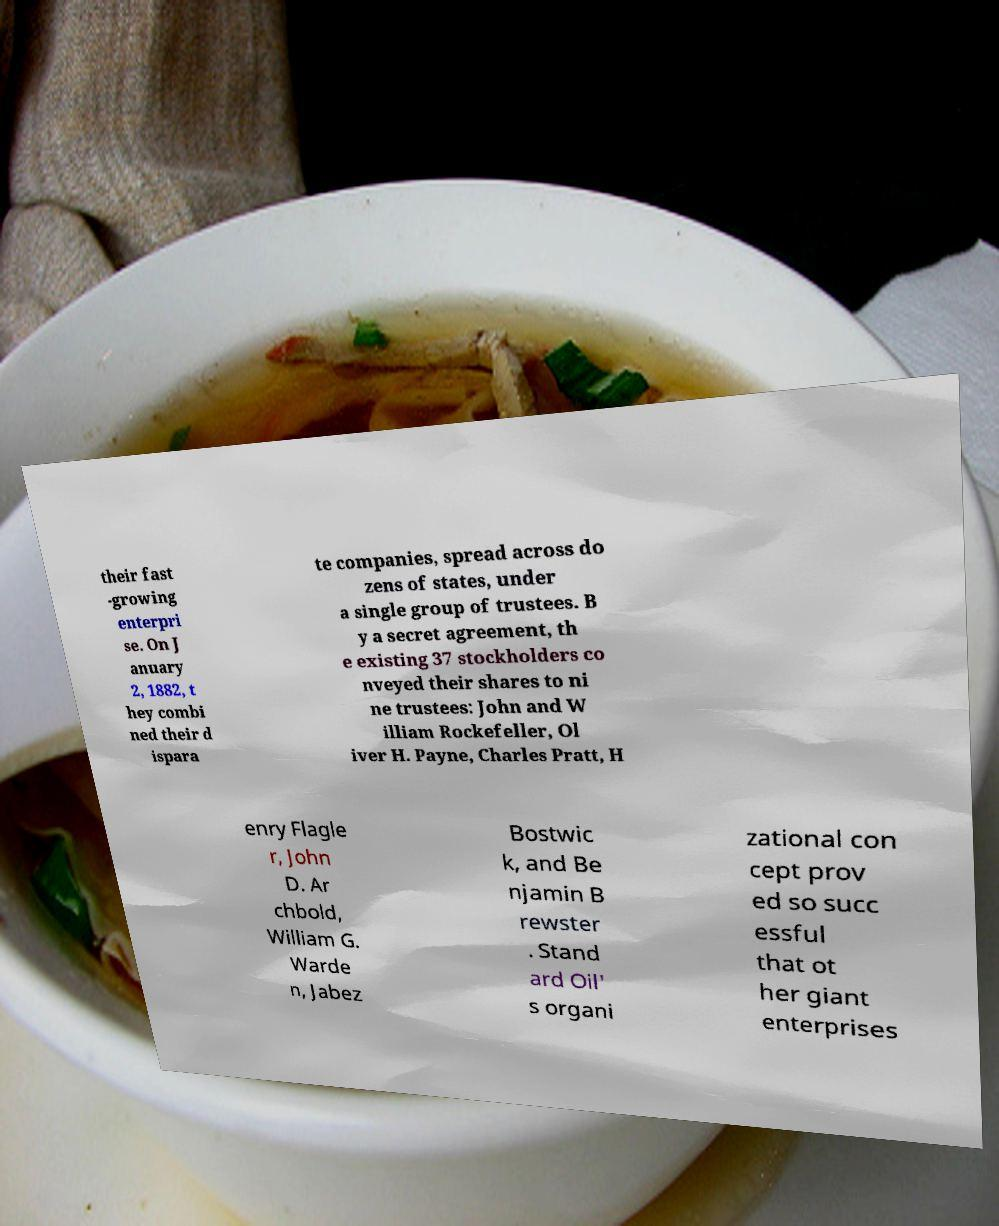For documentation purposes, I need the text within this image transcribed. Could you provide that? their fast -growing enterpri se. On J anuary 2, 1882, t hey combi ned their d ispara te companies, spread across do zens of states, under a single group of trustees. B y a secret agreement, th e existing 37 stockholders co nveyed their shares to ni ne trustees: John and W illiam Rockefeller, Ol iver H. Payne, Charles Pratt, H enry Flagle r, John D. Ar chbold, William G. Warde n, Jabez Bostwic k, and Be njamin B rewster . Stand ard Oil' s organi zational con cept prov ed so succ essful that ot her giant enterprises 